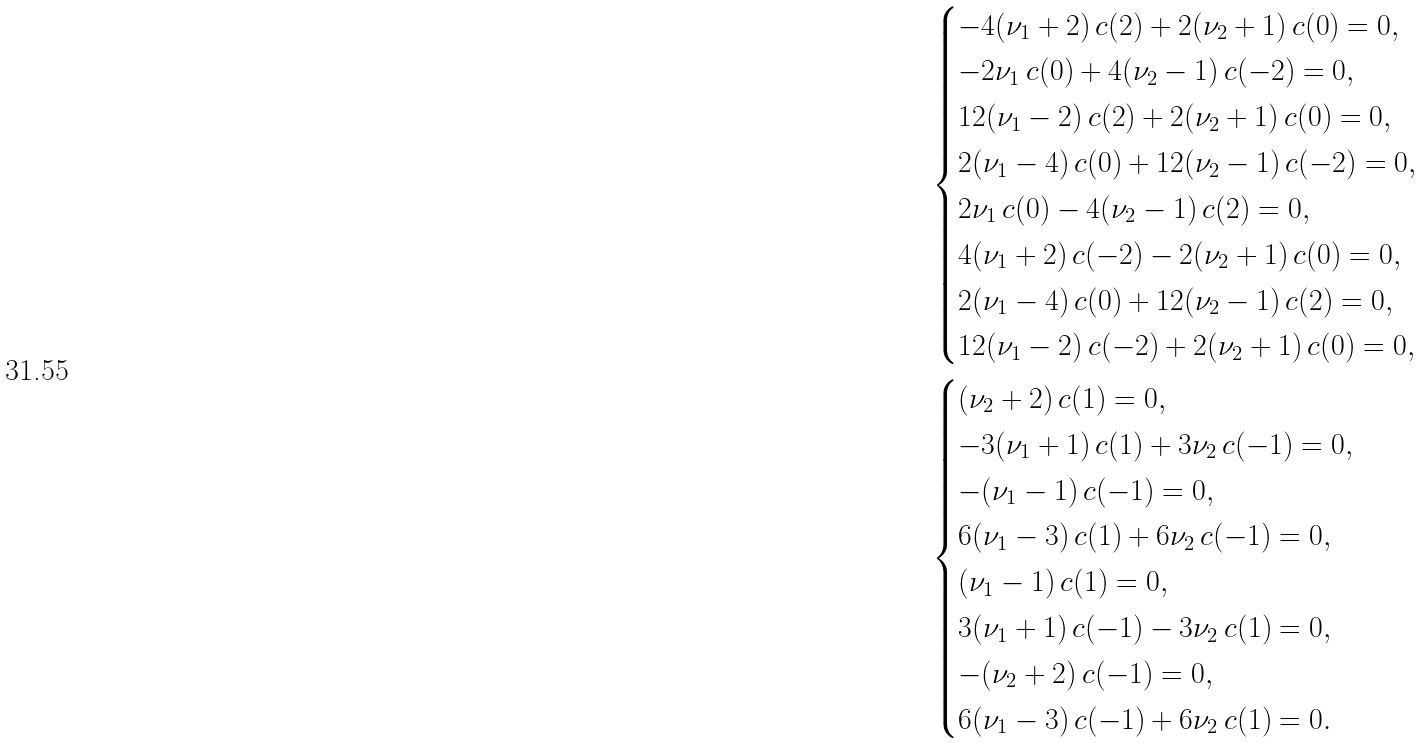Convert formula to latex. <formula><loc_0><loc_0><loc_500><loc_500>& \begin{cases} - 4 ( \nu _ { 1 } + 2 ) \, c ( 2 ) + 2 ( \nu _ { 2 } + 1 ) \, c ( 0 ) = 0 , \\ - 2 \nu _ { 1 } \, c ( 0 ) + 4 ( \nu _ { 2 } - 1 ) \, c ( - 2 ) = 0 , \\ 1 2 ( \nu _ { 1 } - 2 ) \, c ( 2 ) + 2 ( \nu _ { 2 } + 1 ) \, c ( 0 ) = 0 , \\ 2 ( \nu _ { 1 } - 4 ) \, c ( 0 ) + 1 2 ( \nu _ { 2 } - 1 ) \, c ( - 2 ) = 0 , \\ 2 \nu _ { 1 } \, c ( 0 ) - 4 ( \nu _ { 2 } - 1 ) \, c ( 2 ) = 0 , \\ 4 ( \nu _ { 1 } + 2 ) \, c ( - 2 ) - 2 ( \nu _ { 2 } + 1 ) \, c ( 0 ) = 0 , \\ 2 ( \nu _ { 1 } - 4 ) \, c ( 0 ) + 1 2 ( \nu _ { 2 } - 1 ) \, c ( 2 ) = 0 , \\ 1 2 ( \nu _ { 1 } - 2 ) \, c ( - 2 ) + 2 ( \nu _ { 2 } + 1 ) \, c ( 0 ) = 0 , \end{cases} \\ & \begin{cases} ( \nu _ { 2 } + 2 ) \, c ( 1 ) = 0 , \\ - 3 ( \nu _ { 1 } + 1 ) \, c ( 1 ) + 3 \nu _ { 2 } \, c ( - 1 ) = 0 , \\ - ( \nu _ { 1 } - 1 ) \, c ( - 1 ) = 0 , \\ 6 ( \nu _ { 1 } - 3 ) \, c ( 1 ) + 6 \nu _ { 2 } \, c ( - 1 ) = 0 , \\ ( \nu _ { 1 } - 1 ) \, c ( 1 ) = 0 , \\ 3 ( \nu _ { 1 } + 1 ) \, c ( - 1 ) - 3 \nu _ { 2 } \, c ( 1 ) = 0 , \\ - ( \nu _ { 2 } + 2 ) \, c ( - 1 ) = 0 , \\ 6 ( \nu _ { 1 } - 3 ) \, c ( - 1 ) + 6 \nu _ { 2 } \, c ( 1 ) = 0 . \end{cases}</formula> 